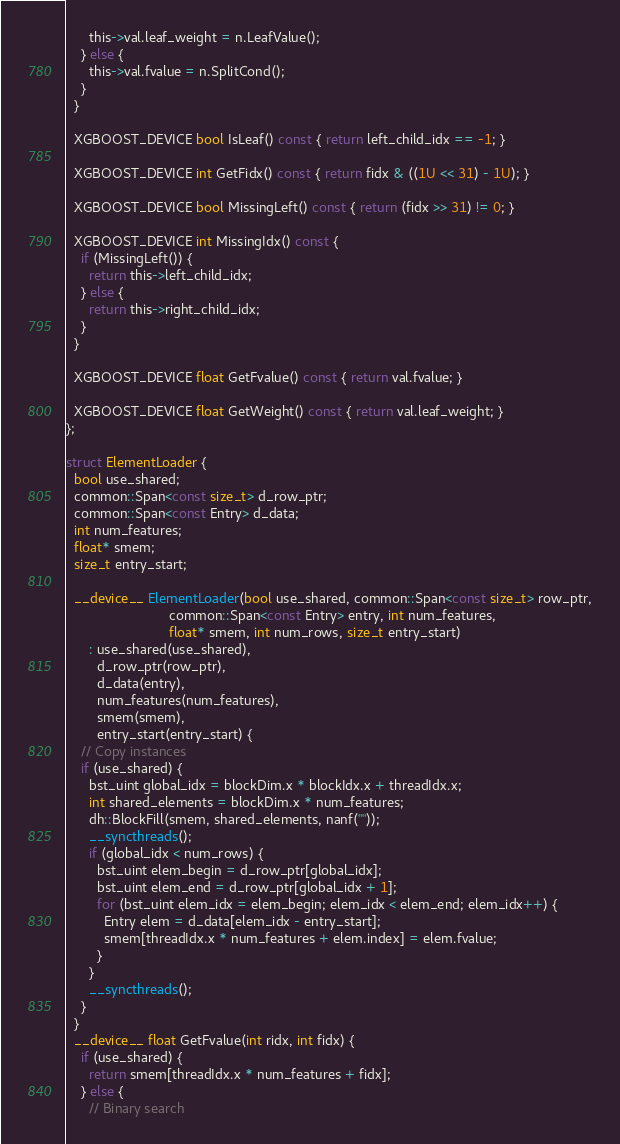<code> <loc_0><loc_0><loc_500><loc_500><_Cuda_>      this->val.leaf_weight = n.LeafValue();
    } else {
      this->val.fvalue = n.SplitCond();
    }
  }

  XGBOOST_DEVICE bool IsLeaf() const { return left_child_idx == -1; }

  XGBOOST_DEVICE int GetFidx() const { return fidx & ((1U << 31) - 1U); }

  XGBOOST_DEVICE bool MissingLeft() const { return (fidx >> 31) != 0; }

  XGBOOST_DEVICE int MissingIdx() const {
    if (MissingLeft()) {
      return this->left_child_idx;
    } else {
      return this->right_child_idx;
    }
  }

  XGBOOST_DEVICE float GetFvalue() const { return val.fvalue; }

  XGBOOST_DEVICE float GetWeight() const { return val.leaf_weight; }
};

struct ElementLoader {
  bool use_shared;
  common::Span<const size_t> d_row_ptr;
  common::Span<const Entry> d_data;
  int num_features;
  float* smem;
  size_t entry_start;

  __device__ ElementLoader(bool use_shared, common::Span<const size_t> row_ptr,
                           common::Span<const Entry> entry, int num_features,
                           float* smem, int num_rows, size_t entry_start)
      : use_shared(use_shared),
        d_row_ptr(row_ptr),
        d_data(entry),
        num_features(num_features),
        smem(smem),
        entry_start(entry_start) {
    // Copy instances
    if (use_shared) {
      bst_uint global_idx = blockDim.x * blockIdx.x + threadIdx.x;
      int shared_elements = blockDim.x * num_features;
      dh::BlockFill(smem, shared_elements, nanf(""));
      __syncthreads();
      if (global_idx < num_rows) {
        bst_uint elem_begin = d_row_ptr[global_idx];
        bst_uint elem_end = d_row_ptr[global_idx + 1];
        for (bst_uint elem_idx = elem_begin; elem_idx < elem_end; elem_idx++) {
          Entry elem = d_data[elem_idx - entry_start];
          smem[threadIdx.x * num_features + elem.index] = elem.fvalue;
        }
      }
      __syncthreads();
    }
  }
  __device__ float GetFvalue(int ridx, int fidx) {
    if (use_shared) {
      return smem[threadIdx.x * num_features + fidx];
    } else {
      // Binary search</code> 